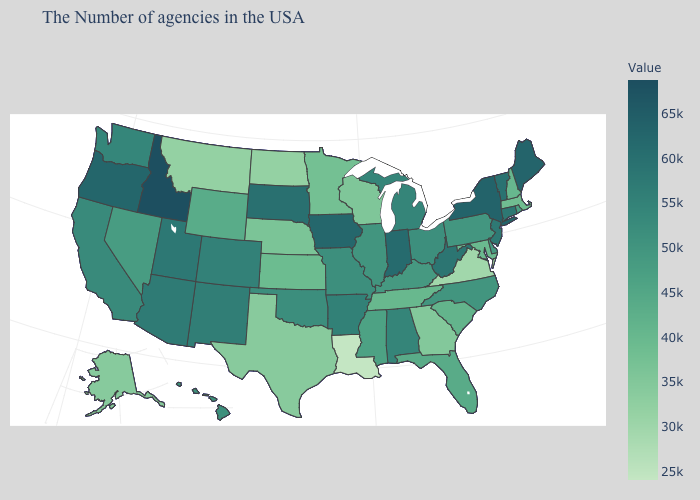Which states have the highest value in the USA?
Give a very brief answer. Idaho. Which states hav the highest value in the MidWest?
Write a very short answer. Iowa. Among the states that border Indiana , which have the highest value?
Be succinct. Michigan. Among the states that border Maine , which have the lowest value?
Write a very short answer. New Hampshire. Which states have the highest value in the USA?
Short answer required. Idaho. Which states have the highest value in the USA?
Short answer required. Idaho. Does Kentucky have a lower value than Arkansas?
Concise answer only. Yes. 